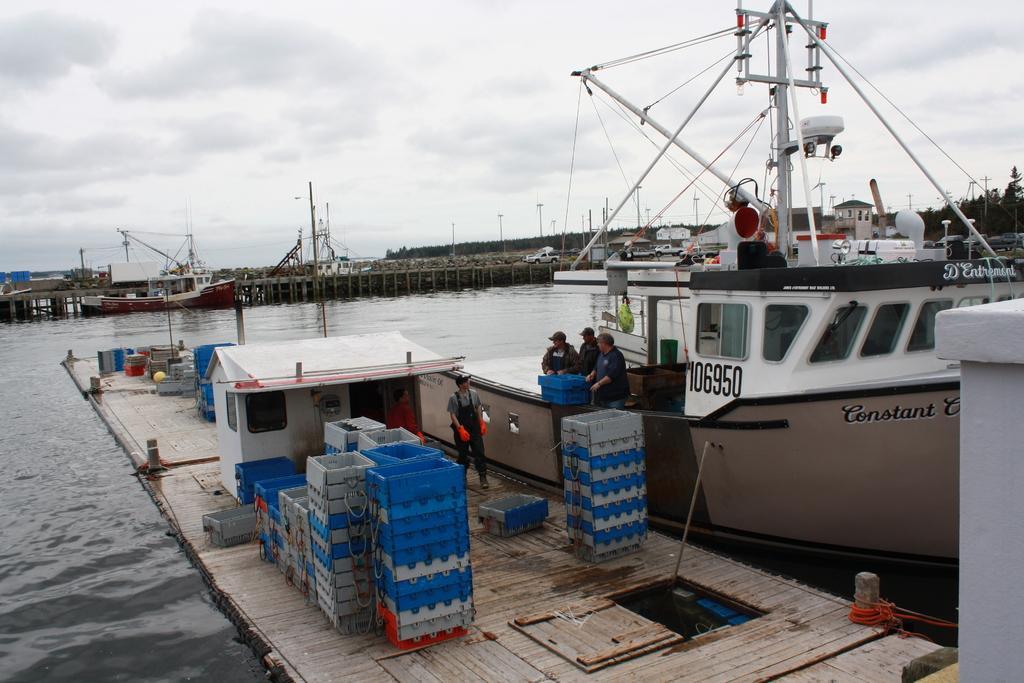In one or two sentences, can you explain what this image depicts? In this image we can see a ship, here are the persons standing, here are the objects, here is the water, here is the bridge, here a car is travelling, here are the trees, at above here is the sky. 